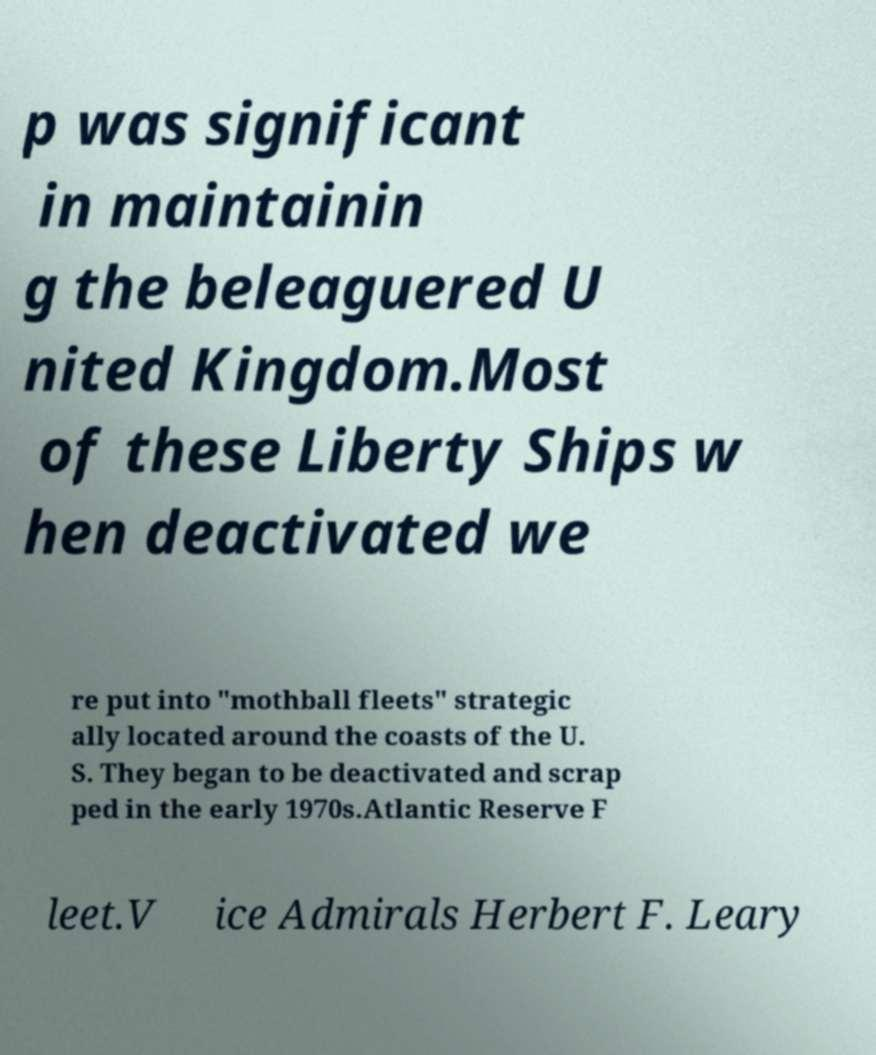Can you accurately transcribe the text from the provided image for me? p was significant in maintainin g the beleaguered U nited Kingdom.Most of these Liberty Ships w hen deactivated we re put into "mothball fleets" strategic ally located around the coasts of the U. S. They began to be deactivated and scrap ped in the early 1970s.Atlantic Reserve F leet.V ice Admirals Herbert F. Leary 